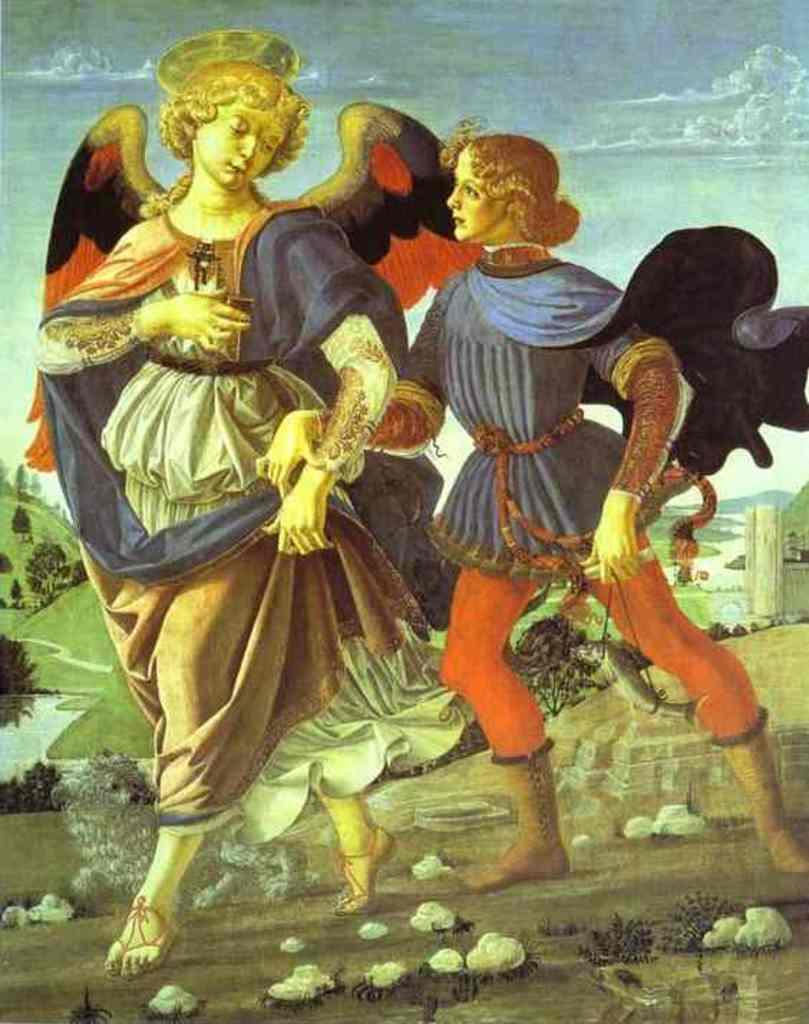What is the main subject of the image? There is a painting in the image. What is depicted in the painting? The painting contains two people. How many carrots are visible in the painting? There are no carrots visible in the painting; it only contains two people. What type of teeth can be seen on the people in the painting? The painting is not a photograph or a realistic depiction, so it does not show teeth. 